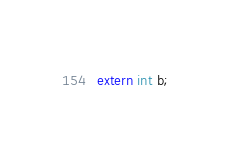Convert code to text. <code><loc_0><loc_0><loc_500><loc_500><_C_>extern int b;
</code> 